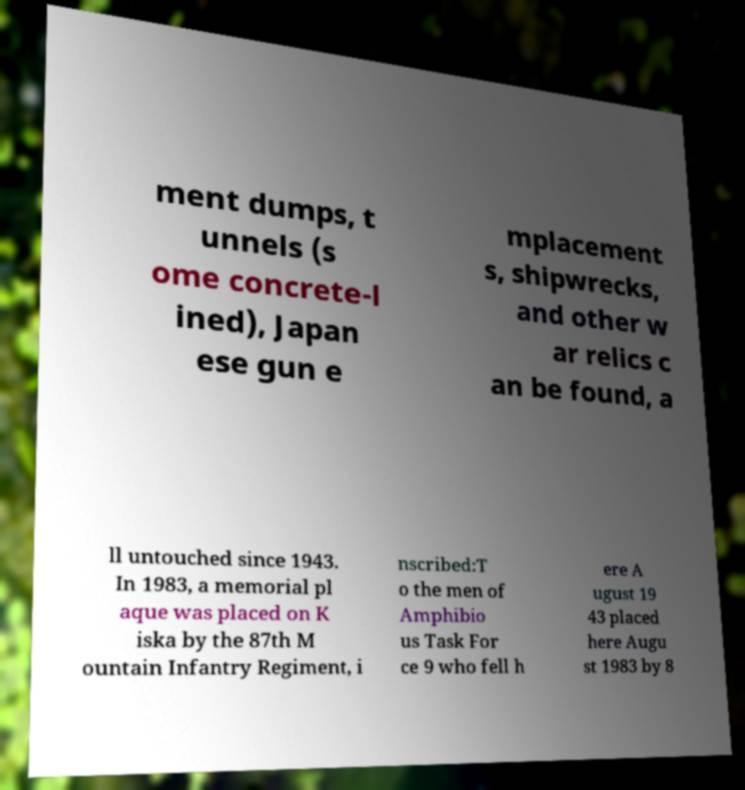What messages or text are displayed in this image? I need them in a readable, typed format. ment dumps, t unnels (s ome concrete-l ined), Japan ese gun e mplacement s, shipwrecks, and other w ar relics c an be found, a ll untouched since 1943. In 1983, a memorial pl aque was placed on K iska by the 87th M ountain Infantry Regiment, i nscribed:T o the men of Amphibio us Task For ce 9 who fell h ere A ugust 19 43 placed here Augu st 1983 by 8 